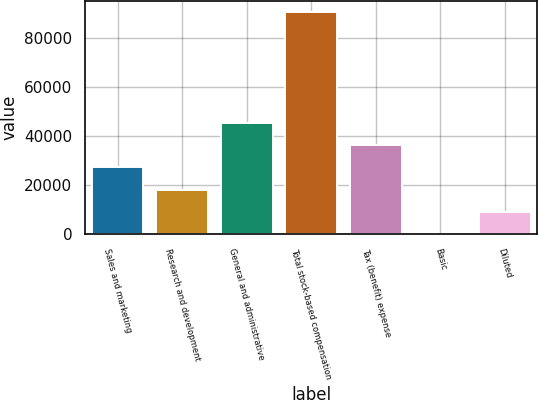Convert chart to OTSL. <chart><loc_0><loc_0><loc_500><loc_500><bar_chart><fcel>Sales and marketing<fcel>Research and development<fcel>General and administrative<fcel>Total stock-based compensation<fcel>Tax (benefit) expense<fcel>Basic<fcel>Diluted<nl><fcel>27274.4<fcel>18183<fcel>45457.1<fcel>90914<fcel>36365.8<fcel>0.29<fcel>9091.66<nl></chart> 